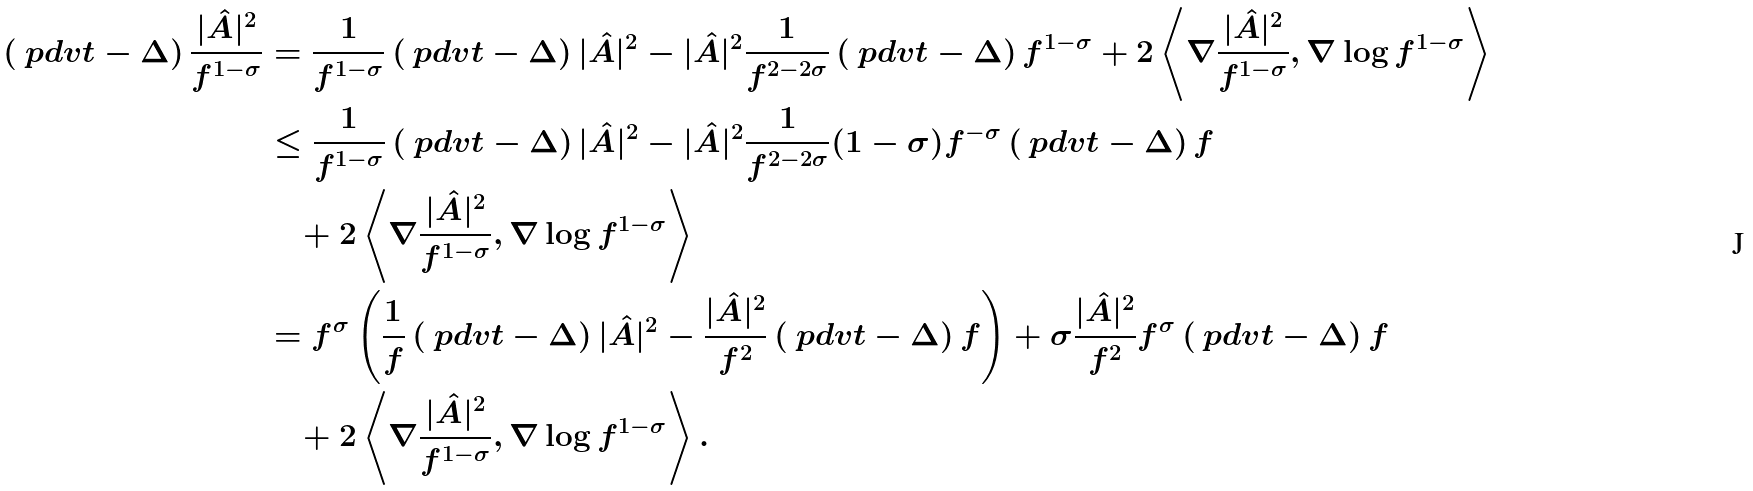Convert formula to latex. <formula><loc_0><loc_0><loc_500><loc_500>\left ( \ p d v { t } - \Delta \right ) \frac { | \hat { A } | ^ { 2 } } { f ^ { 1 - \sigma } } & = \frac { 1 } { f ^ { 1 - \sigma } } \left ( \ p d v { t } - \Delta \right ) | \hat { A } | ^ { 2 } - | \hat { A } | ^ { 2 } \frac { 1 } { f ^ { 2 - 2 \sigma } } \left ( \ p d v { t } - \Delta \right ) f ^ { 1 - \sigma } + 2 \left \langle \nabla \frac { | \hat { A } | ^ { 2 } } { f ^ { 1 - \sigma } } , \nabla \log f ^ { 1 - \sigma } \right \rangle \\ & \leq \frac { 1 } { f ^ { 1 - \sigma } } \left ( \ p d v { t } - \Delta \right ) | \hat { A } | ^ { 2 } - | \hat { A } | ^ { 2 } \frac { 1 } { f ^ { 2 - 2 \sigma } } ( 1 - \sigma ) f ^ { - \sigma } \left ( \ p d v { t } - \Delta \right ) f \\ & \quad + 2 \left \langle \nabla \frac { | \hat { A } | ^ { 2 } } { f ^ { 1 - \sigma } } , \nabla \log f ^ { 1 - \sigma } \right \rangle \\ & = f ^ { \sigma } \left ( \frac { 1 } { f } \left ( \ p d v { t } - \Delta \right ) | \hat { A } | ^ { 2 } - \frac { | \hat { A } | ^ { 2 } } { f ^ { 2 } } \left ( \ p d v { t } - \Delta \right ) f \right ) + \sigma \frac { | \hat { A } | ^ { 2 } } { f ^ { 2 } } f ^ { \sigma } \left ( \ p d v { t } - \Delta \right ) f \\ & \quad + 2 \left \langle \nabla \frac { | \hat { A } | ^ { 2 } } { f ^ { 1 - \sigma } } , \nabla \log f ^ { 1 - \sigma } \right \rangle .</formula> 